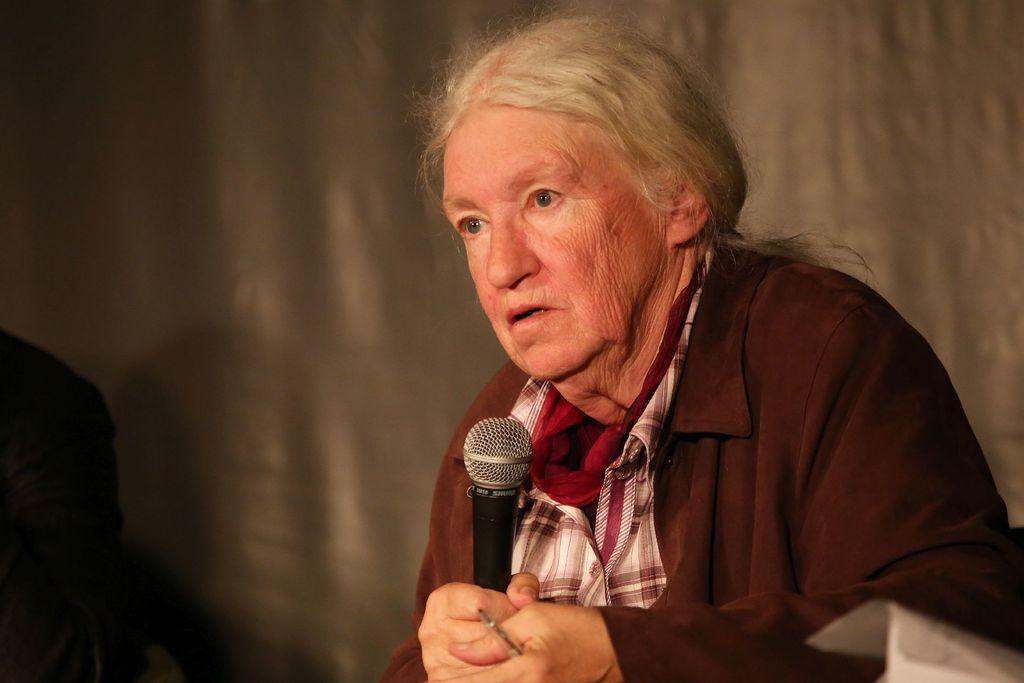Could you give a brief overview of what you see in this image? In this given image there is a old woman, holding a mic in her hand. She's wearing a red shirt. In the background we can observe a wall here. 